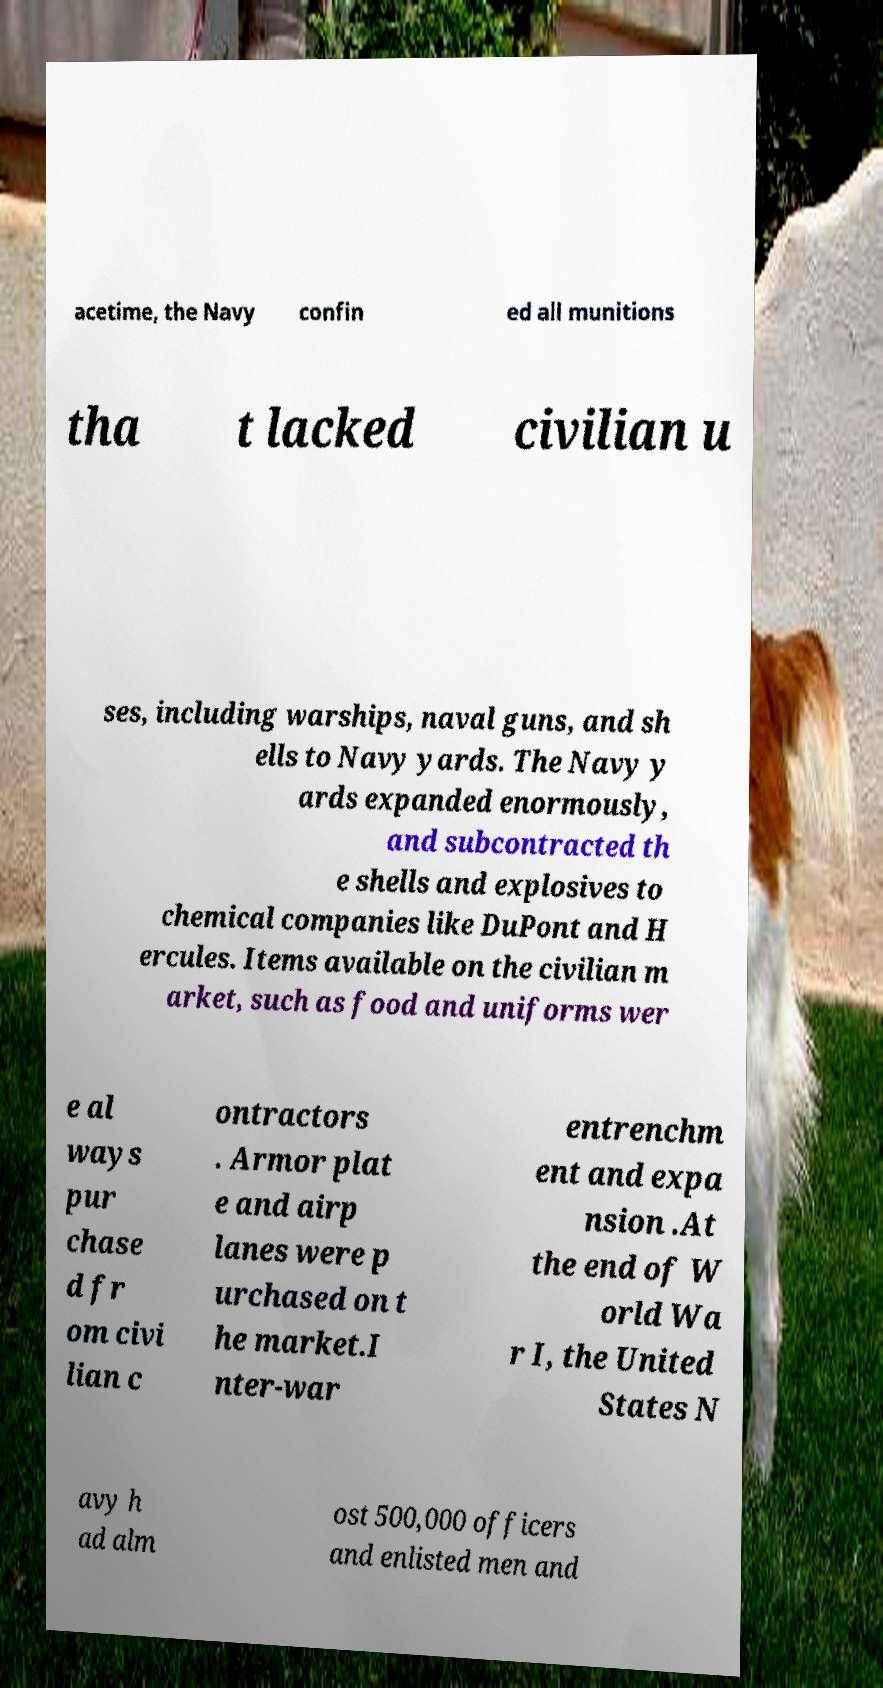Please identify and transcribe the text found in this image. acetime, the Navy confin ed all munitions tha t lacked civilian u ses, including warships, naval guns, and sh ells to Navy yards. The Navy y ards expanded enormously, and subcontracted th e shells and explosives to chemical companies like DuPont and H ercules. Items available on the civilian m arket, such as food and uniforms wer e al ways pur chase d fr om civi lian c ontractors . Armor plat e and airp lanes were p urchased on t he market.I nter-war entrenchm ent and expa nsion .At the end of W orld Wa r I, the United States N avy h ad alm ost 500,000 officers and enlisted men and 